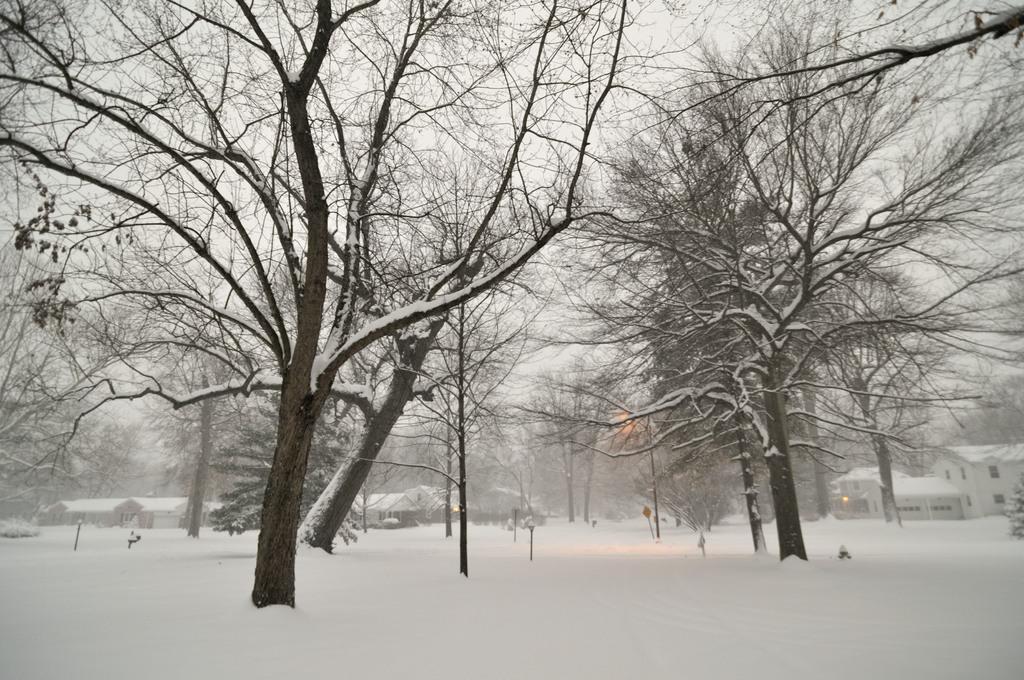Describe this image in one or two sentences. We can see snow,trees,poles and board. In the background we can see houses and sky. 